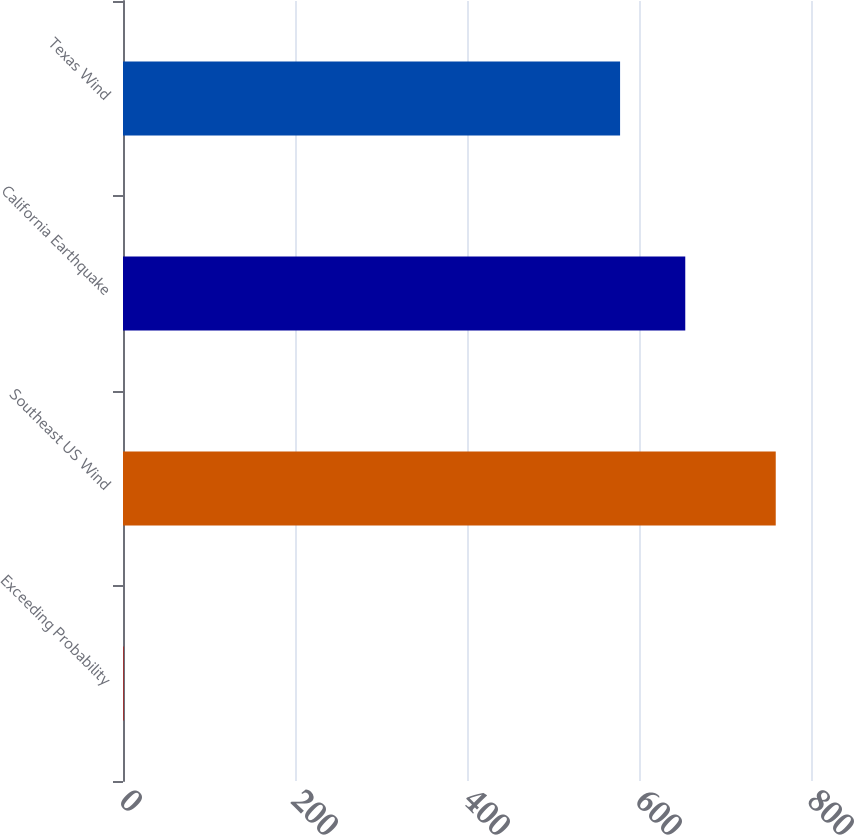Convert chart. <chart><loc_0><loc_0><loc_500><loc_500><bar_chart><fcel>Exceeding Probability<fcel>Southeast US Wind<fcel>California Earthquake<fcel>Texas Wind<nl><fcel>1<fcel>759<fcel>653.8<fcel>578<nl></chart> 